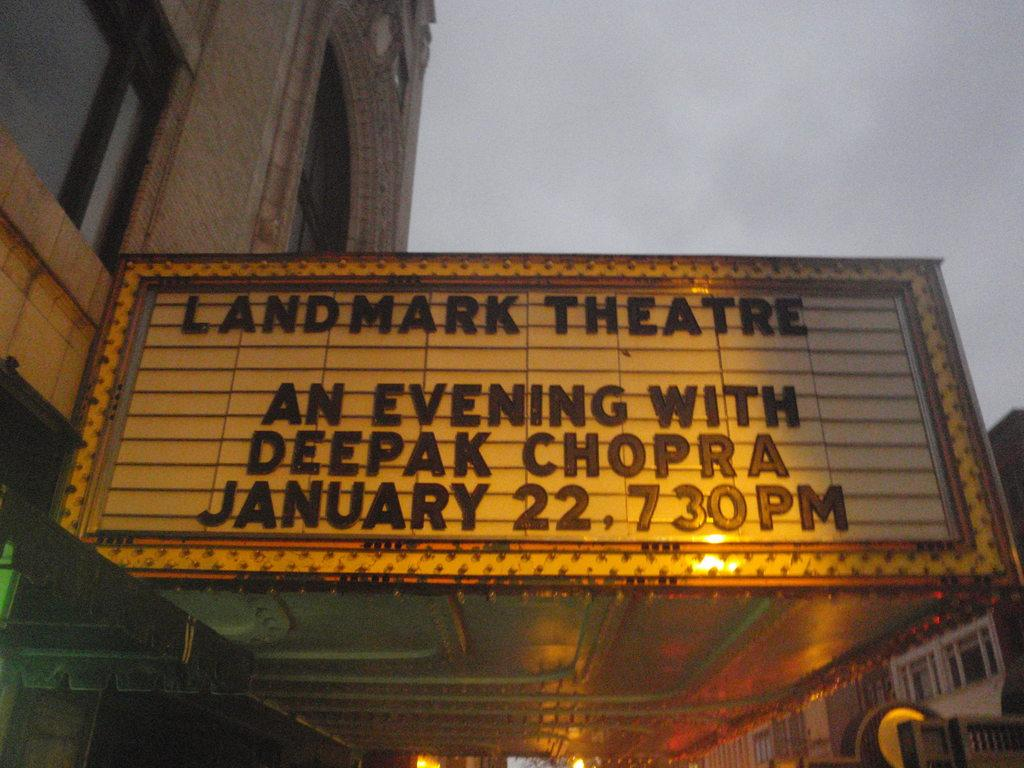What is the main subject of the image? The main subject of the image is a theater board. What information is displayed on the theater board? "Landmark theater" is written on the board. What can be seen behind the theater board? There is a brown building behind the theater board. What type of windows does the building have? The building has glass windows. Is there a veil covering the theater board in the image? No, there is no veil covering the theater board in the image. Can you see a clam attached to the brown building in the image? No, there is no clam present in the image. 